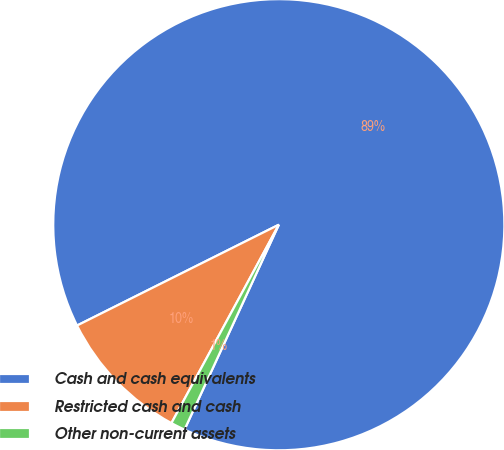<chart> <loc_0><loc_0><loc_500><loc_500><pie_chart><fcel>Cash and cash equivalents<fcel>Restricted cash and cash<fcel>Other non-current assets<nl><fcel>89.24%<fcel>9.73%<fcel>1.03%<nl></chart> 